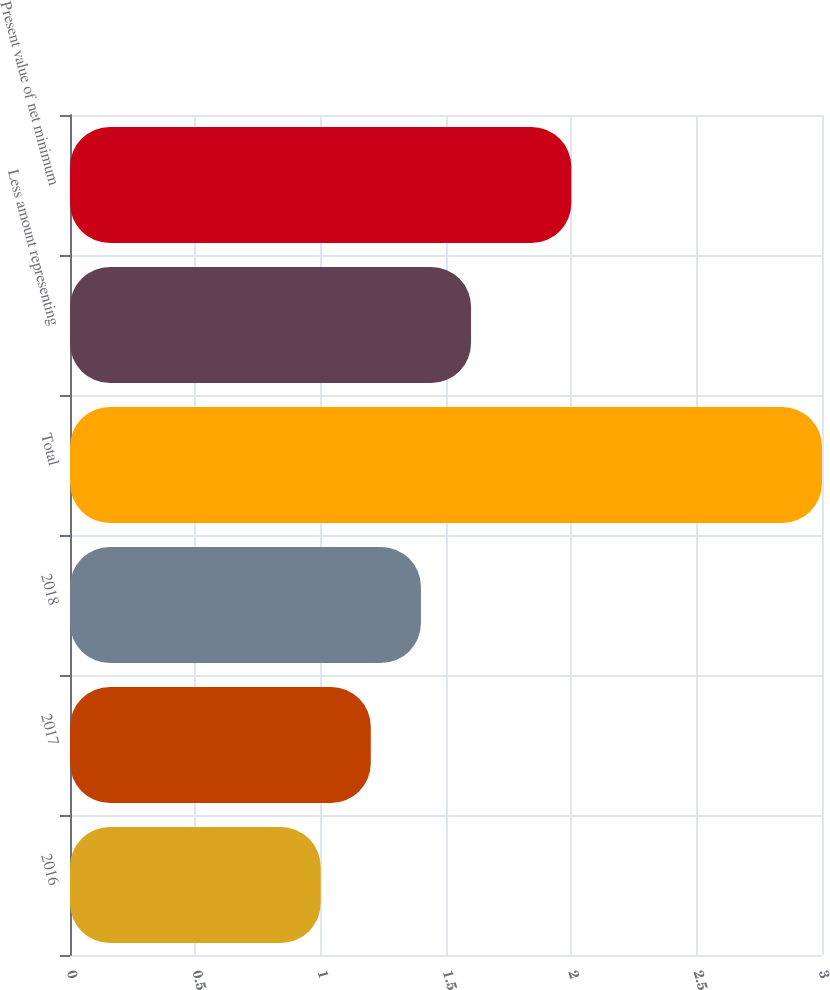Convert chart to OTSL. <chart><loc_0><loc_0><loc_500><loc_500><bar_chart><fcel>2016<fcel>2017<fcel>2018<fcel>Total<fcel>Less amount representing<fcel>Present value of net minimum<nl><fcel>1<fcel>1.2<fcel>1.4<fcel>3<fcel>1.6<fcel>2<nl></chart> 